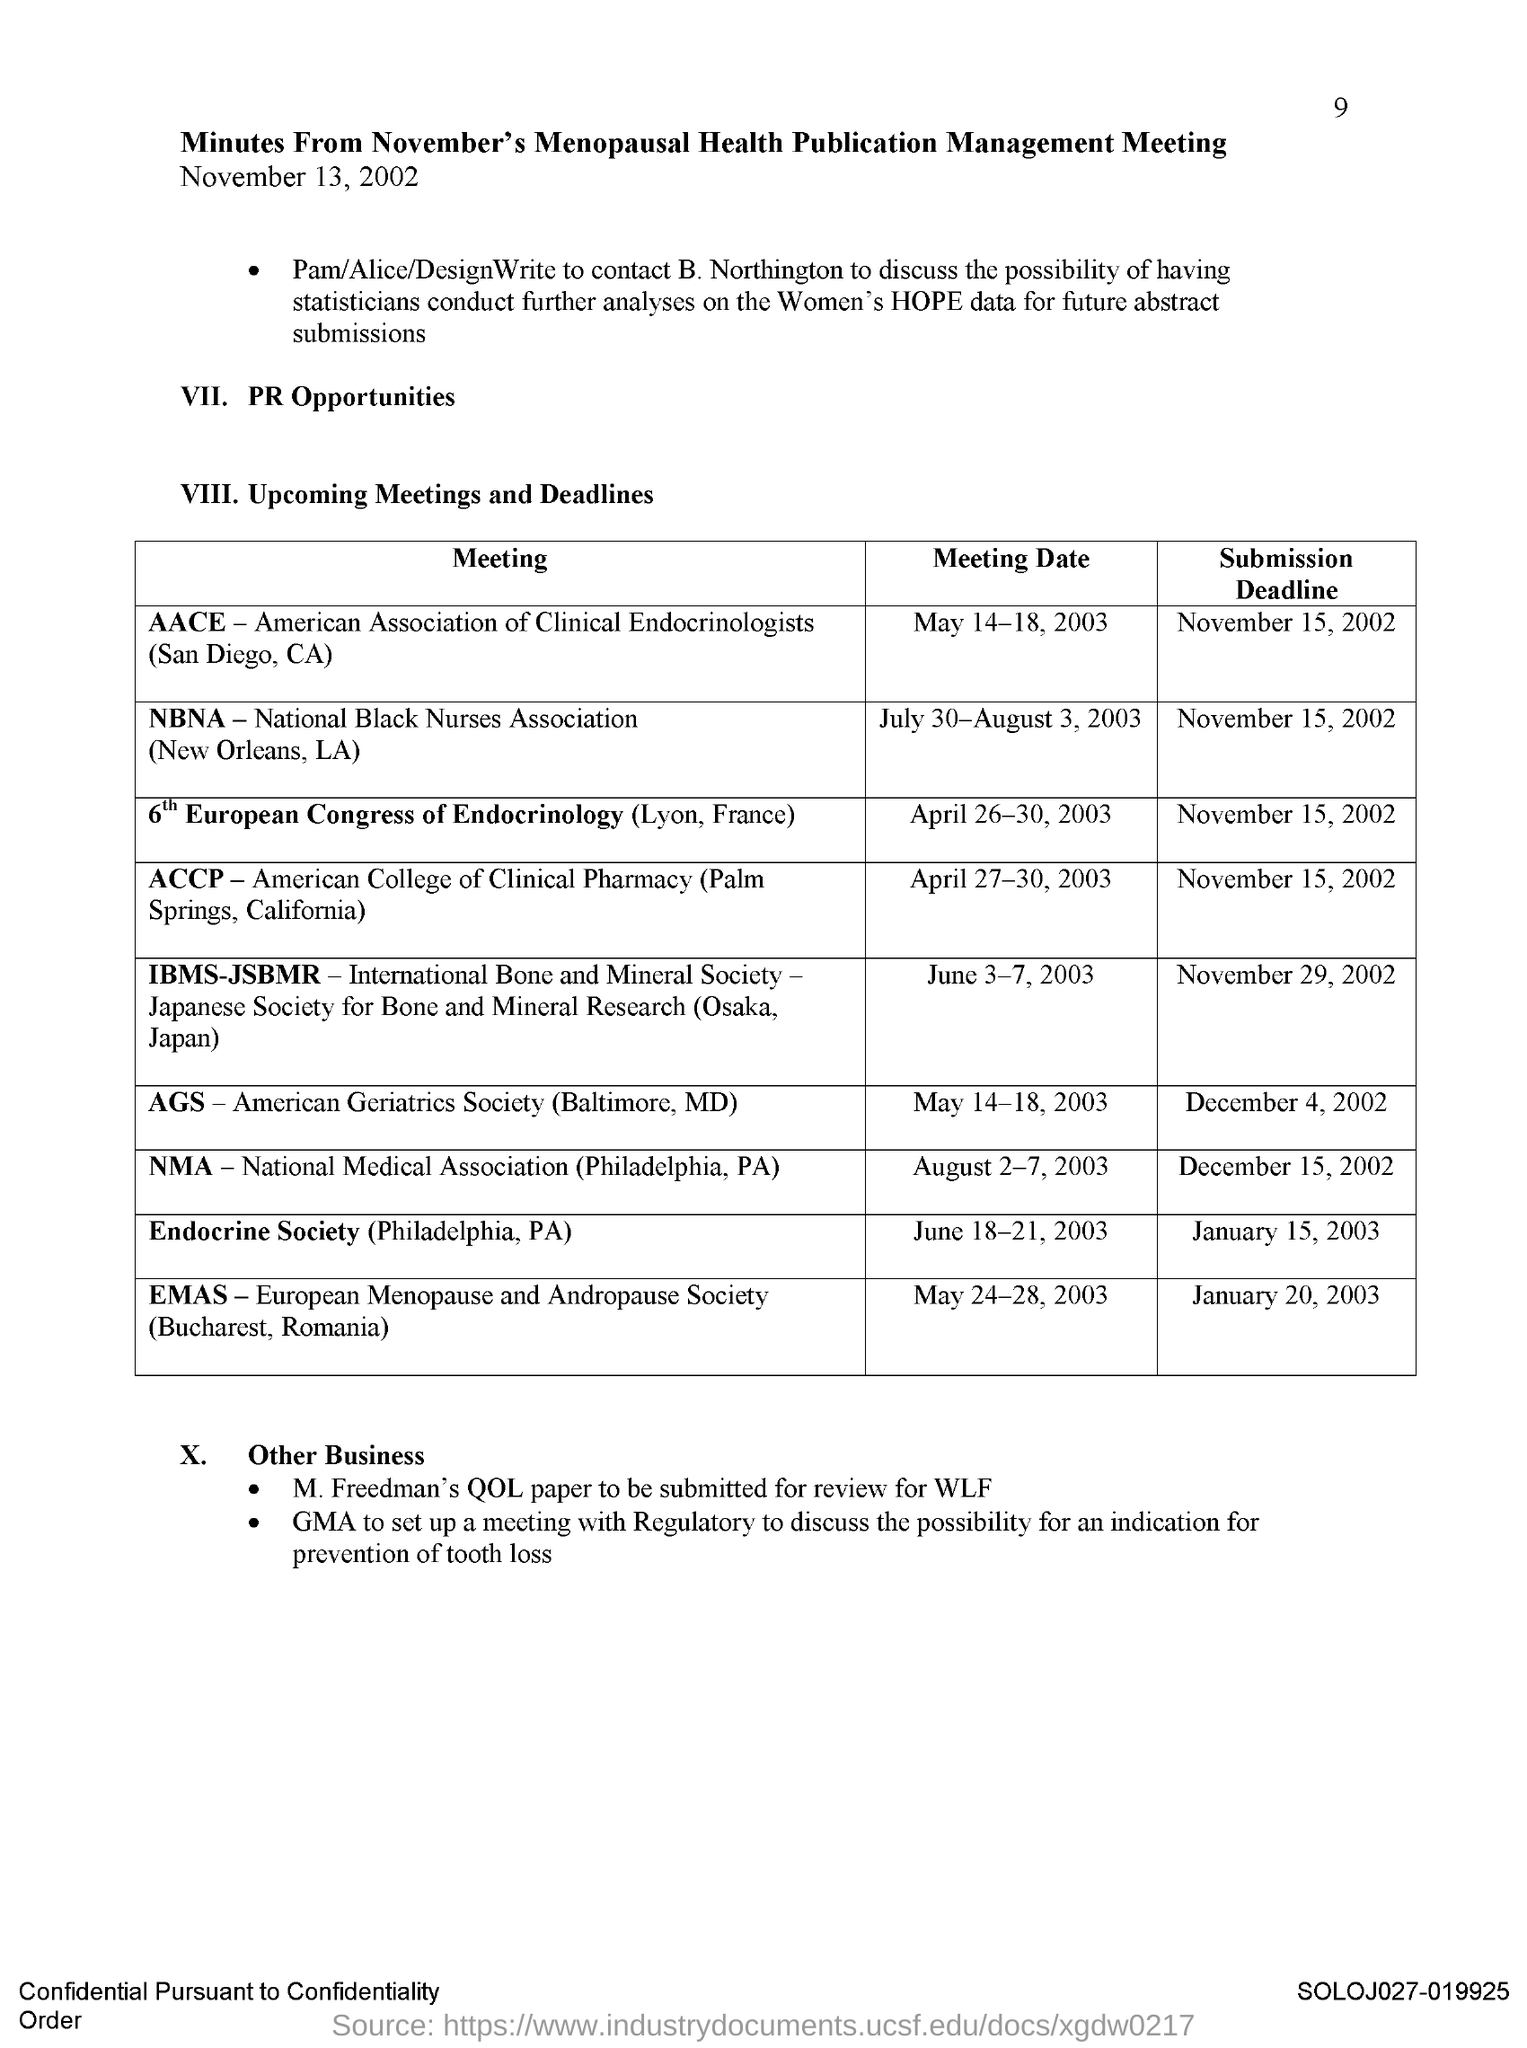What is the Submission Deadline for AACE Meeting?
Ensure brevity in your answer.  November 15, 2002. What is the Submission Deadline for NBNA Meeting?
Give a very brief answer. November 15, 2002. What is the Submission Deadline for 6th European Congress of Endocrinology?
Keep it short and to the point. November 15, 2002. What is the Submission Deadline for ACCP Meeting?
Ensure brevity in your answer.  November 15, 2002. What is the Submission Deadline for IBMS-JSBMR Meeting?
Offer a terse response. November 29, 2002. What is the Submission Deadline for AGS Meeting?
Make the answer very short. December 4, 2002. What is the Submission Deadline for NMA Meeting?
Your answer should be very brief. December 15, 2002. What is the Submission Deadline for EMAS Meeting?
Your answer should be compact. January 20, 2003. What is the Meeting Date for NBNA Meeting?
Provide a short and direct response. July 30-August 3, 2003. 